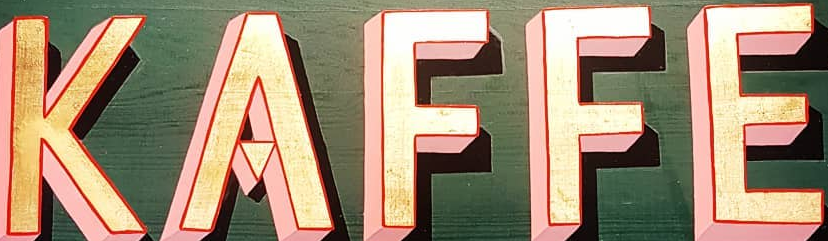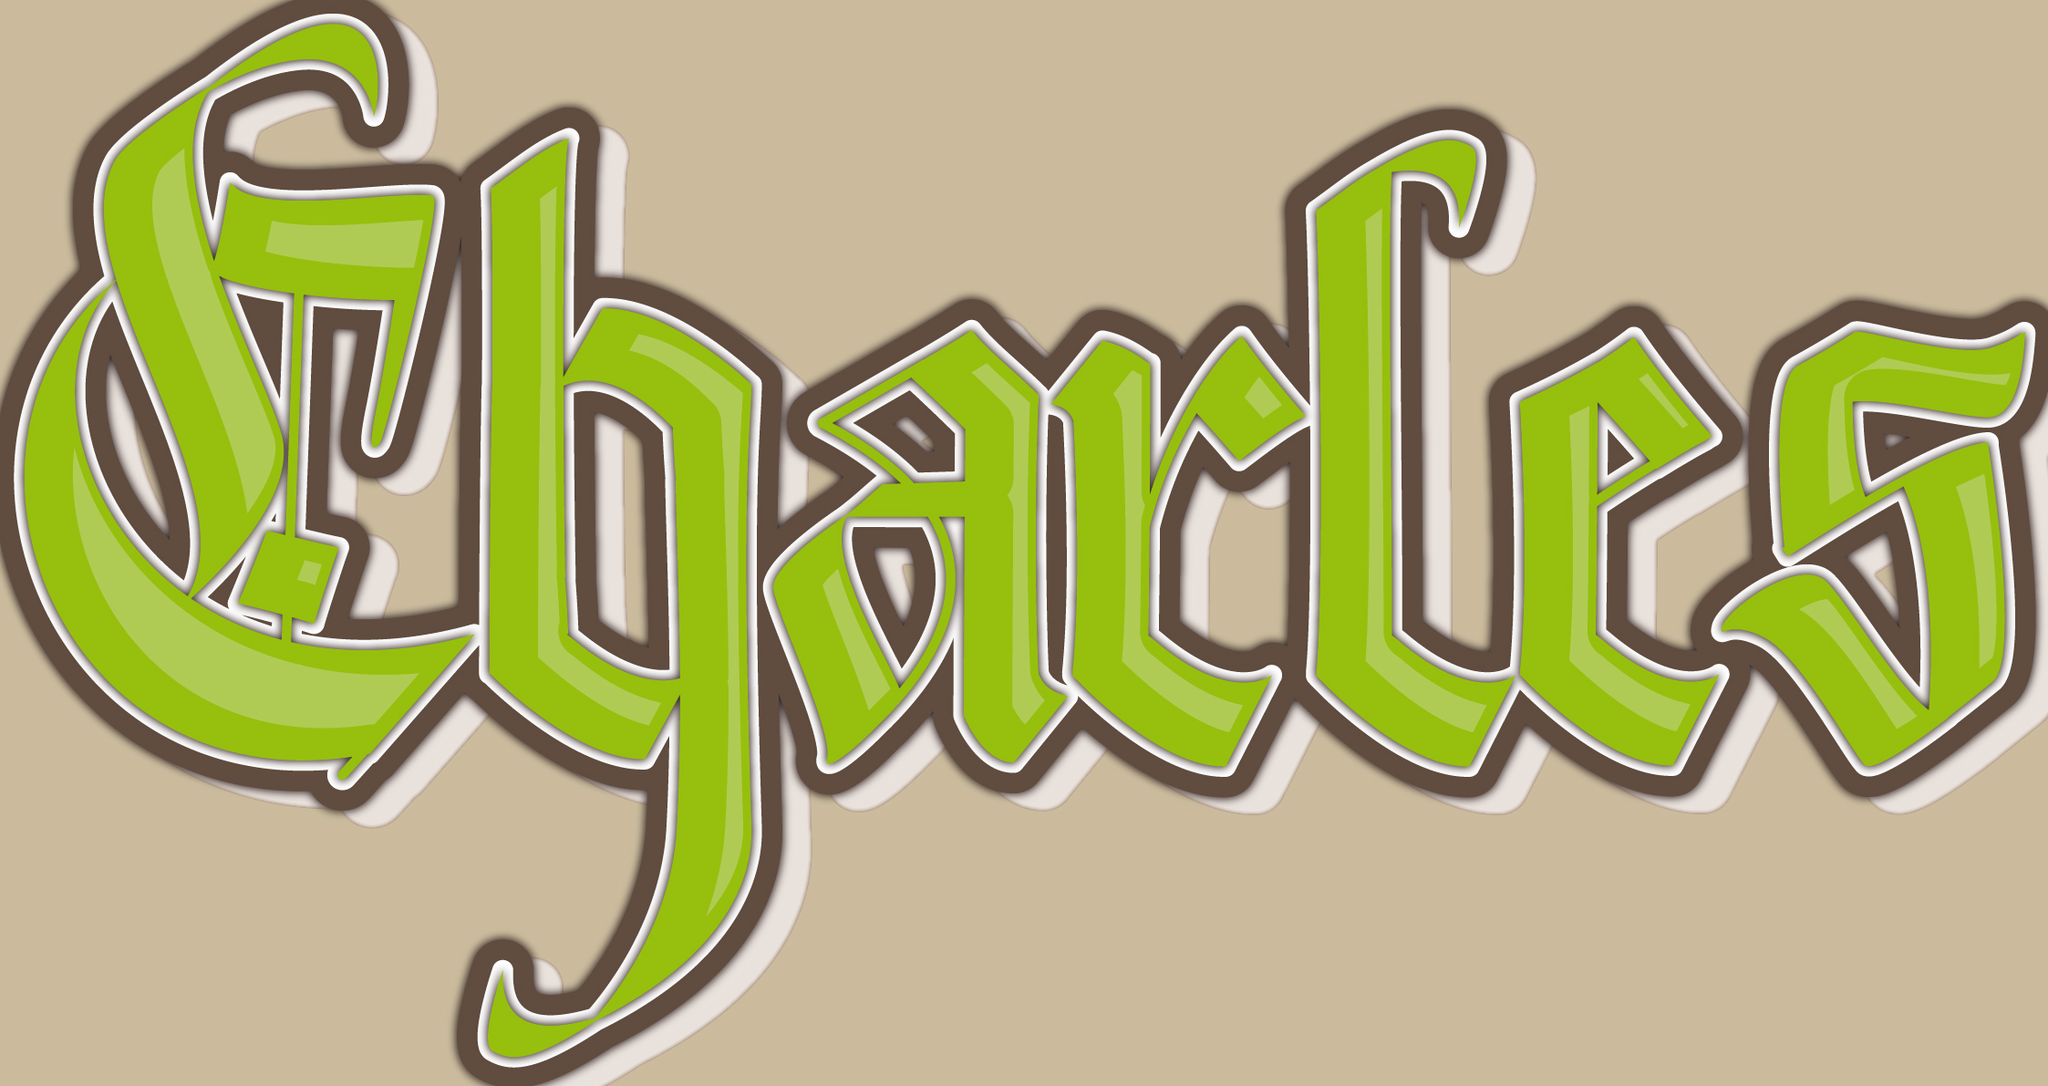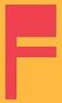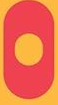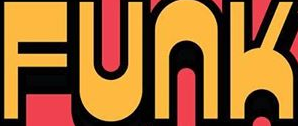What words are shown in these images in order, separated by a semicolon? KAFFE; Charles; F; O; FUNK 